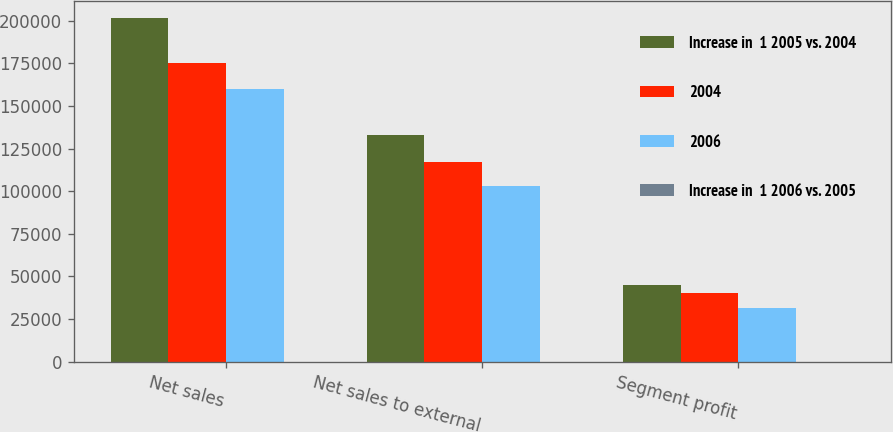Convert chart to OTSL. <chart><loc_0><loc_0><loc_500><loc_500><stacked_bar_chart><ecel><fcel>Net sales<fcel>Net sales to external<fcel>Segment profit<nl><fcel>Increase in  1 2005 vs. 2004<fcel>201431<fcel>132710<fcel>45160<nl><fcel>2004<fcel>174909<fcel>116912<fcel>40245<nl><fcel>2006<fcel>159784<fcel>102867<fcel>31705<nl><fcel>Increase in  1 2006 vs. 2005<fcel>15<fcel>14<fcel>12<nl></chart> 